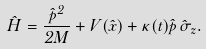Convert formula to latex. <formula><loc_0><loc_0><loc_500><loc_500>\hat { H } = \frac { \hat { p } ^ { 2 } } { 2 M } + V ( \hat { x } ) + \kappa ( t ) \hat { p } \, \hat { \sigma } _ { z } .</formula> 